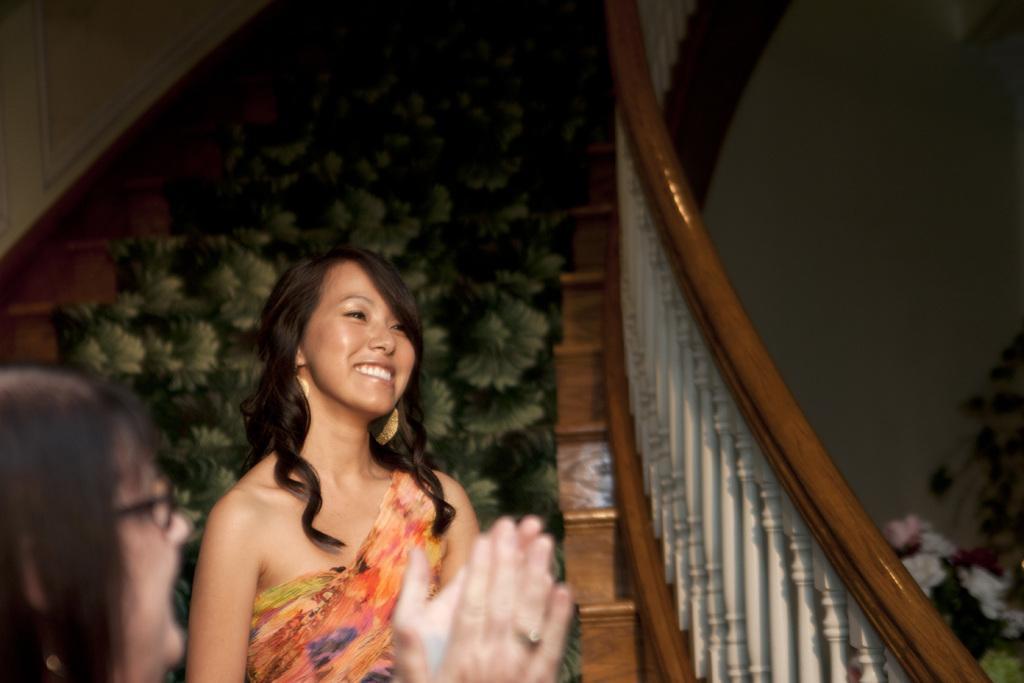Please provide a concise description of this image. In this image, we can see two persons in front of the staircase. There is a carpet in the middle of the image. There is a plant in the bottom right of the image. 